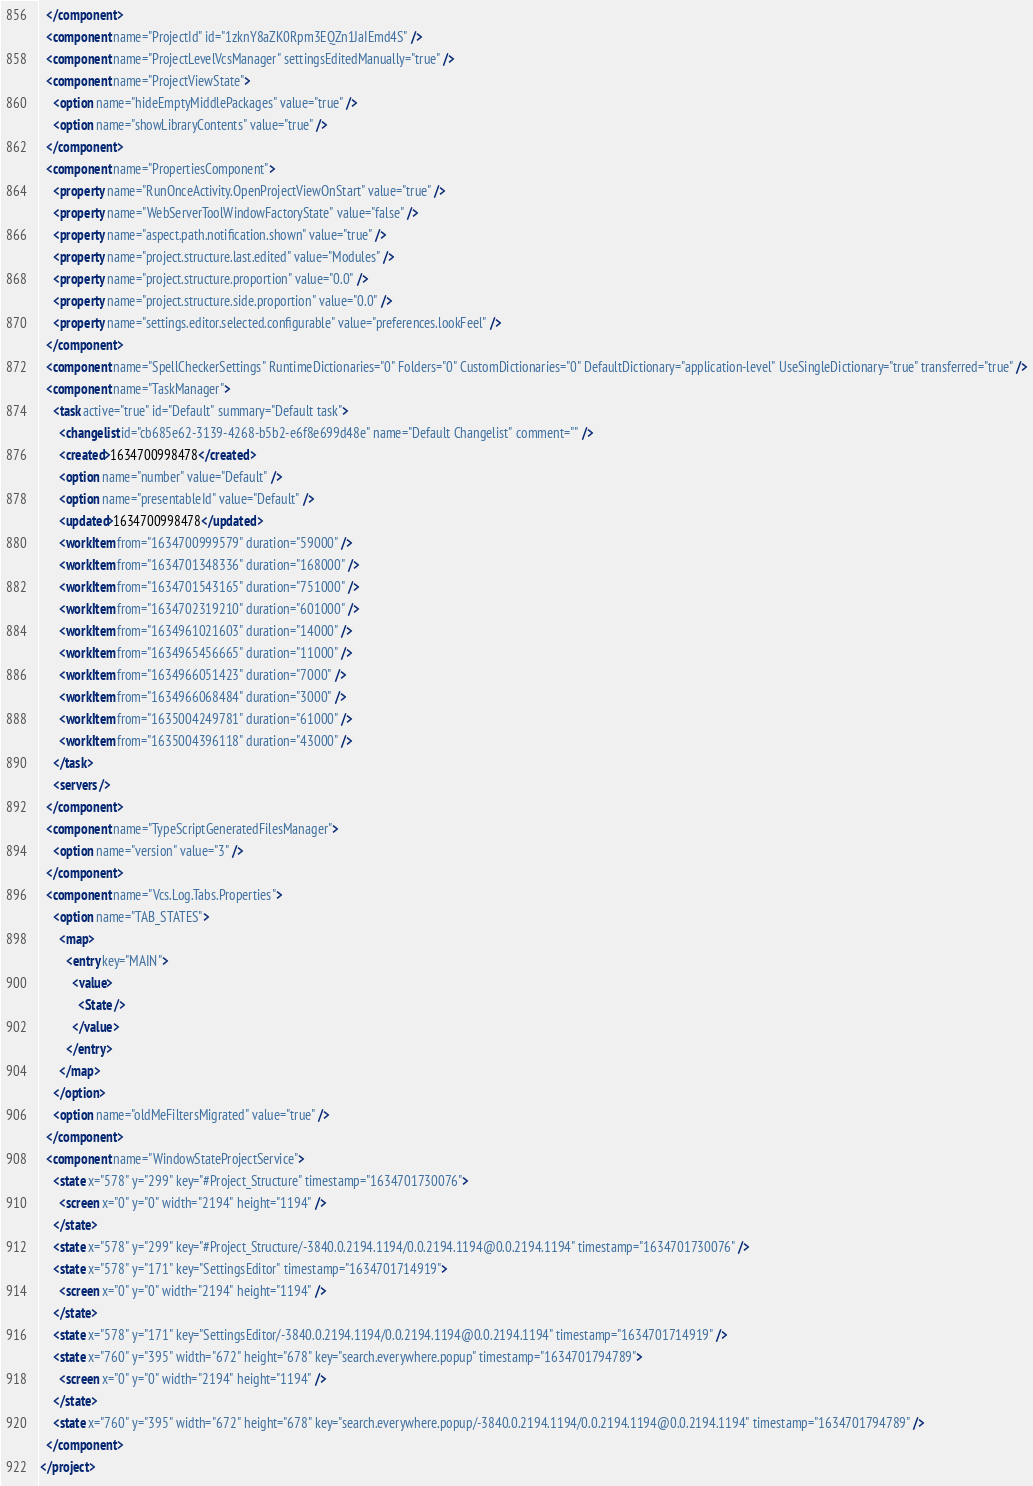<code> <loc_0><loc_0><loc_500><loc_500><_XML_>  </component>
  <component name="ProjectId" id="1zknY8aZK0Rpm3EQZn1JaIEmd4S" />
  <component name="ProjectLevelVcsManager" settingsEditedManually="true" />
  <component name="ProjectViewState">
    <option name="hideEmptyMiddlePackages" value="true" />
    <option name="showLibraryContents" value="true" />
  </component>
  <component name="PropertiesComponent">
    <property name="RunOnceActivity.OpenProjectViewOnStart" value="true" />
    <property name="WebServerToolWindowFactoryState" value="false" />
    <property name="aspect.path.notification.shown" value="true" />
    <property name="project.structure.last.edited" value="Modules" />
    <property name="project.structure.proportion" value="0.0" />
    <property name="project.structure.side.proportion" value="0.0" />
    <property name="settings.editor.selected.configurable" value="preferences.lookFeel" />
  </component>
  <component name="SpellCheckerSettings" RuntimeDictionaries="0" Folders="0" CustomDictionaries="0" DefaultDictionary="application-level" UseSingleDictionary="true" transferred="true" />
  <component name="TaskManager">
    <task active="true" id="Default" summary="Default task">
      <changelist id="cb685e62-3139-4268-b5b2-e6f8e699d48e" name="Default Changelist" comment="" />
      <created>1634700998478</created>
      <option name="number" value="Default" />
      <option name="presentableId" value="Default" />
      <updated>1634700998478</updated>
      <workItem from="1634700999579" duration="59000" />
      <workItem from="1634701348336" duration="168000" />
      <workItem from="1634701543165" duration="751000" />
      <workItem from="1634702319210" duration="601000" />
      <workItem from="1634961021603" duration="14000" />
      <workItem from="1634965456665" duration="11000" />
      <workItem from="1634966051423" duration="7000" />
      <workItem from="1634966068484" duration="3000" />
      <workItem from="1635004249781" duration="61000" />
      <workItem from="1635004396118" duration="43000" />
    </task>
    <servers />
  </component>
  <component name="TypeScriptGeneratedFilesManager">
    <option name="version" value="3" />
  </component>
  <component name="Vcs.Log.Tabs.Properties">
    <option name="TAB_STATES">
      <map>
        <entry key="MAIN">
          <value>
            <State />
          </value>
        </entry>
      </map>
    </option>
    <option name="oldMeFiltersMigrated" value="true" />
  </component>
  <component name="WindowStateProjectService">
    <state x="578" y="299" key="#Project_Structure" timestamp="1634701730076">
      <screen x="0" y="0" width="2194" height="1194" />
    </state>
    <state x="578" y="299" key="#Project_Structure/-3840.0.2194.1194/0.0.2194.1194@0.0.2194.1194" timestamp="1634701730076" />
    <state x="578" y="171" key="SettingsEditor" timestamp="1634701714919">
      <screen x="0" y="0" width="2194" height="1194" />
    </state>
    <state x="578" y="171" key="SettingsEditor/-3840.0.2194.1194/0.0.2194.1194@0.0.2194.1194" timestamp="1634701714919" />
    <state x="760" y="395" width="672" height="678" key="search.everywhere.popup" timestamp="1634701794789">
      <screen x="0" y="0" width="2194" height="1194" />
    </state>
    <state x="760" y="395" width="672" height="678" key="search.everywhere.popup/-3840.0.2194.1194/0.0.2194.1194@0.0.2194.1194" timestamp="1634701794789" />
  </component>
</project></code> 